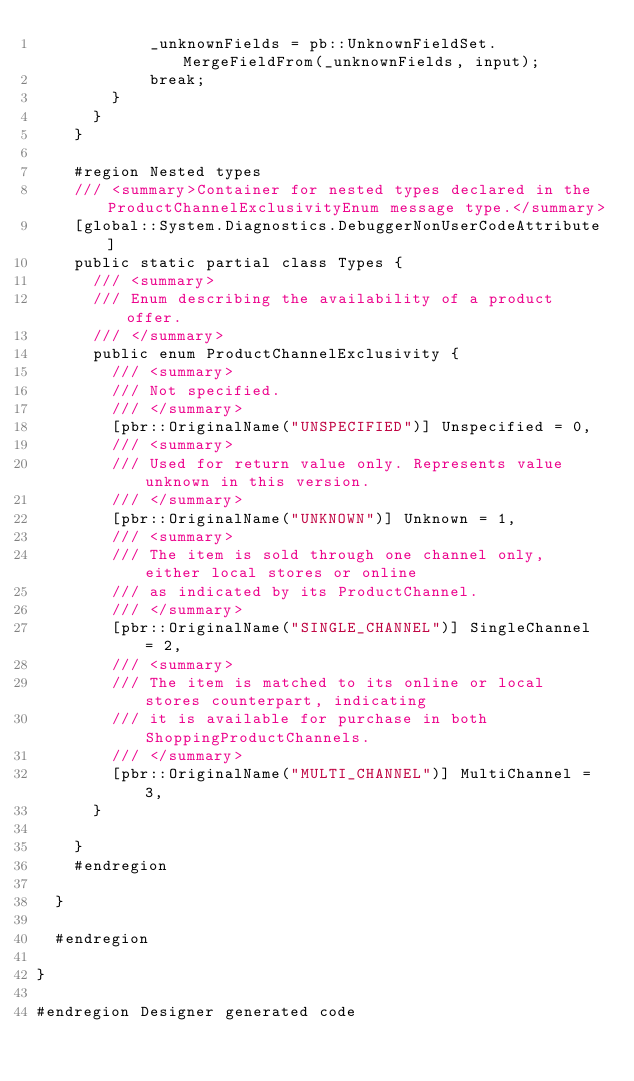<code> <loc_0><loc_0><loc_500><loc_500><_C#_>            _unknownFields = pb::UnknownFieldSet.MergeFieldFrom(_unknownFields, input);
            break;
        }
      }
    }

    #region Nested types
    /// <summary>Container for nested types declared in the ProductChannelExclusivityEnum message type.</summary>
    [global::System.Diagnostics.DebuggerNonUserCodeAttribute]
    public static partial class Types {
      /// <summary>
      /// Enum describing the availability of a product offer.
      /// </summary>
      public enum ProductChannelExclusivity {
        /// <summary>
        /// Not specified.
        /// </summary>
        [pbr::OriginalName("UNSPECIFIED")] Unspecified = 0,
        /// <summary>
        /// Used for return value only. Represents value unknown in this version.
        /// </summary>
        [pbr::OriginalName("UNKNOWN")] Unknown = 1,
        /// <summary>
        /// The item is sold through one channel only, either local stores or online
        /// as indicated by its ProductChannel.
        /// </summary>
        [pbr::OriginalName("SINGLE_CHANNEL")] SingleChannel = 2,
        /// <summary>
        /// The item is matched to its online or local stores counterpart, indicating
        /// it is available for purchase in both ShoppingProductChannels.
        /// </summary>
        [pbr::OriginalName("MULTI_CHANNEL")] MultiChannel = 3,
      }

    }
    #endregion

  }

  #endregion

}

#endregion Designer generated code
</code> 